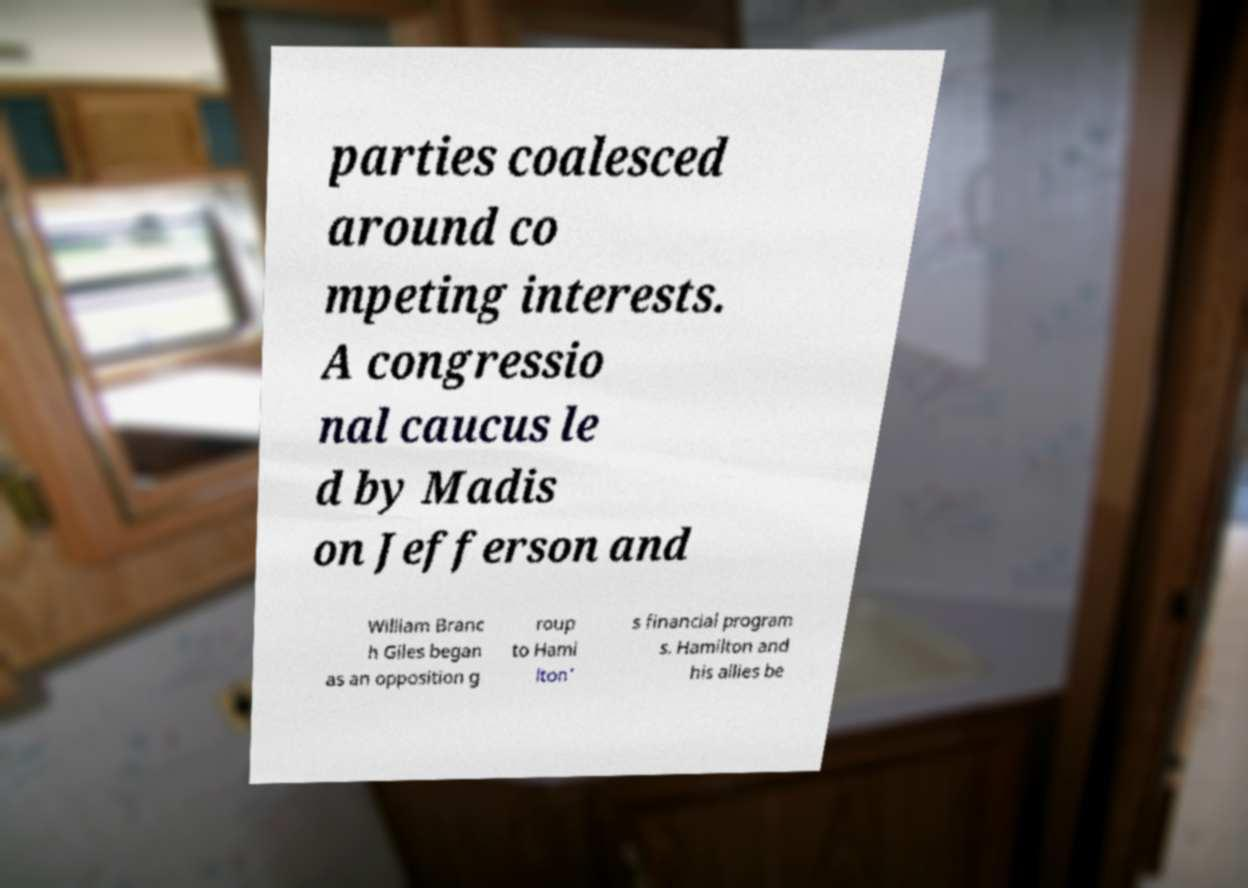What messages or text are displayed in this image? I need them in a readable, typed format. parties coalesced around co mpeting interests. A congressio nal caucus le d by Madis on Jefferson and William Branc h Giles began as an opposition g roup to Hami lton' s financial program s. Hamilton and his allies be 